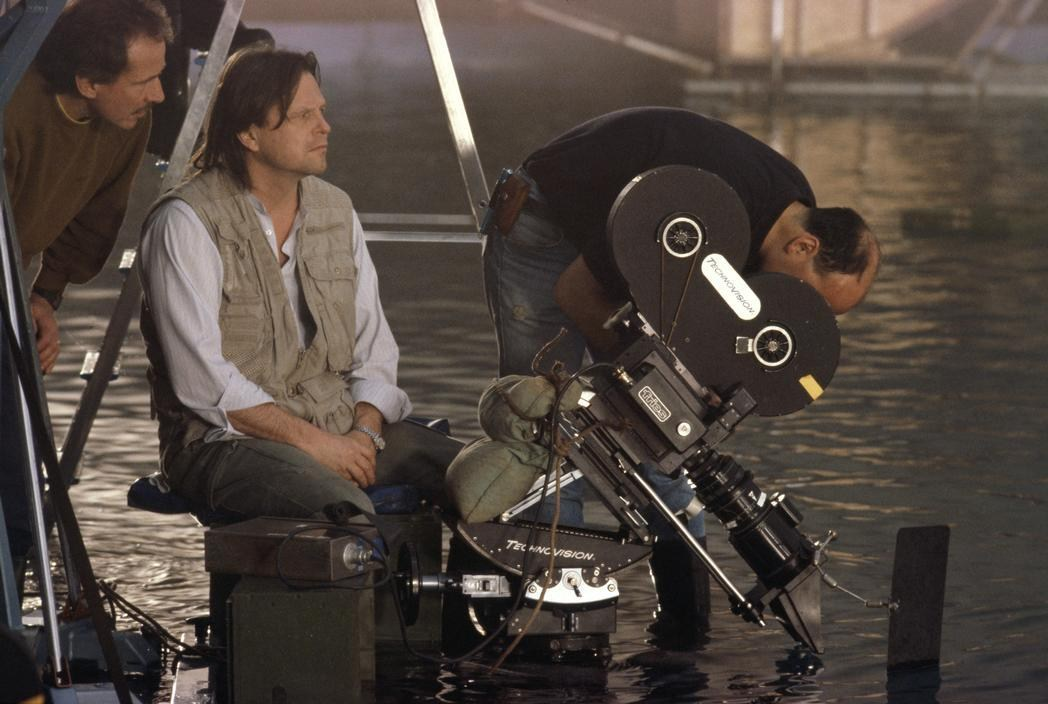What type of film or scene might they be shooting based on the equipment and environment shown? Based on the equipment and environment shown in the image, they are likely shooting a film or scene that involves significant interaction with water, potentially a sequence set in a flood or an environment where water plays a critical role. The presence of a sophisticated Panavision camera, partially submerged, indicates that the water is a major element in the scene. This setup suggests they could be filming a dramatic escape, a rescue operation, or an intense action sequence. The reflective surfaces and the outdoor location hint at a compelling visual dynamic that the filmmakers are aiming to capture, possibly to heighten the realism and impact of the scene. 